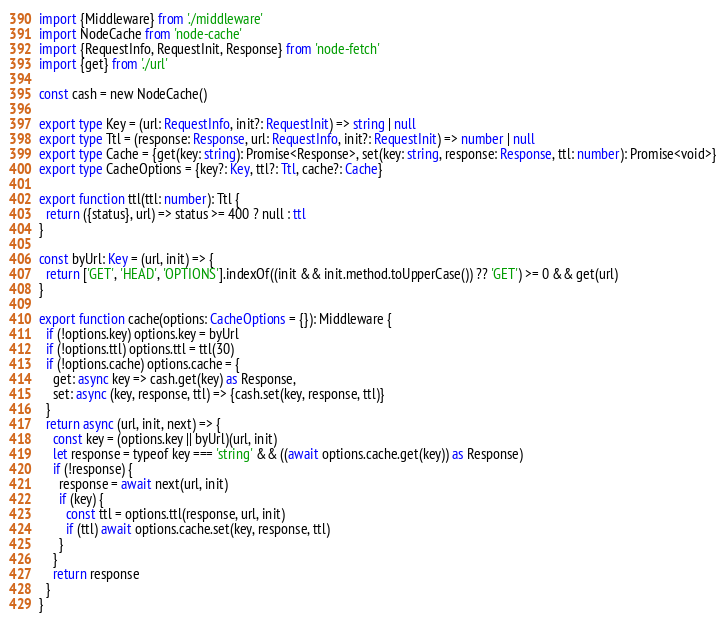<code> <loc_0><loc_0><loc_500><loc_500><_TypeScript_>import {Middleware} from './middleware'
import NodeCache from 'node-cache'
import {RequestInfo, RequestInit, Response} from 'node-fetch'
import {get} from './url'

const cash = new NodeCache()

export type Key = (url: RequestInfo, init?: RequestInit) => string | null
export type Ttl = (response: Response, url: RequestInfo, init?: RequestInit) => number | null
export type Cache = {get(key: string): Promise<Response>, set(key: string, response: Response, ttl: number): Promise<void>}
export type CacheOptions = {key?: Key, ttl?: Ttl, cache?: Cache}

export function ttl(ttl: number): Ttl {
  return ({status}, url) => status >= 400 ? null : ttl
}

const byUrl: Key = (url, init) => {
  return ['GET', 'HEAD', 'OPTIONS'].indexOf((init && init.method.toUpperCase()) ?? 'GET') >= 0 && get(url)
}

export function cache(options: CacheOptions = {}): Middleware {
  if (!options.key) options.key = byUrl
  if (!options.ttl) options.ttl = ttl(30)
  if (!options.cache) options.cache = {
    get: async key => cash.get(key) as Response,
    set: async (key, response, ttl) => {cash.set(key, response, ttl)}
  }
  return async (url, init, next) => {
    const key = (options.key || byUrl)(url, init)
    let response = typeof key === 'string' && ((await options.cache.get(key)) as Response)
    if (!response) {
      response = await next(url, init)
      if (key) {
        const ttl = options.ttl(response, url, init)
        if (ttl) await options.cache.set(key, response, ttl)
      }
    }
    return response
  }
}
</code> 